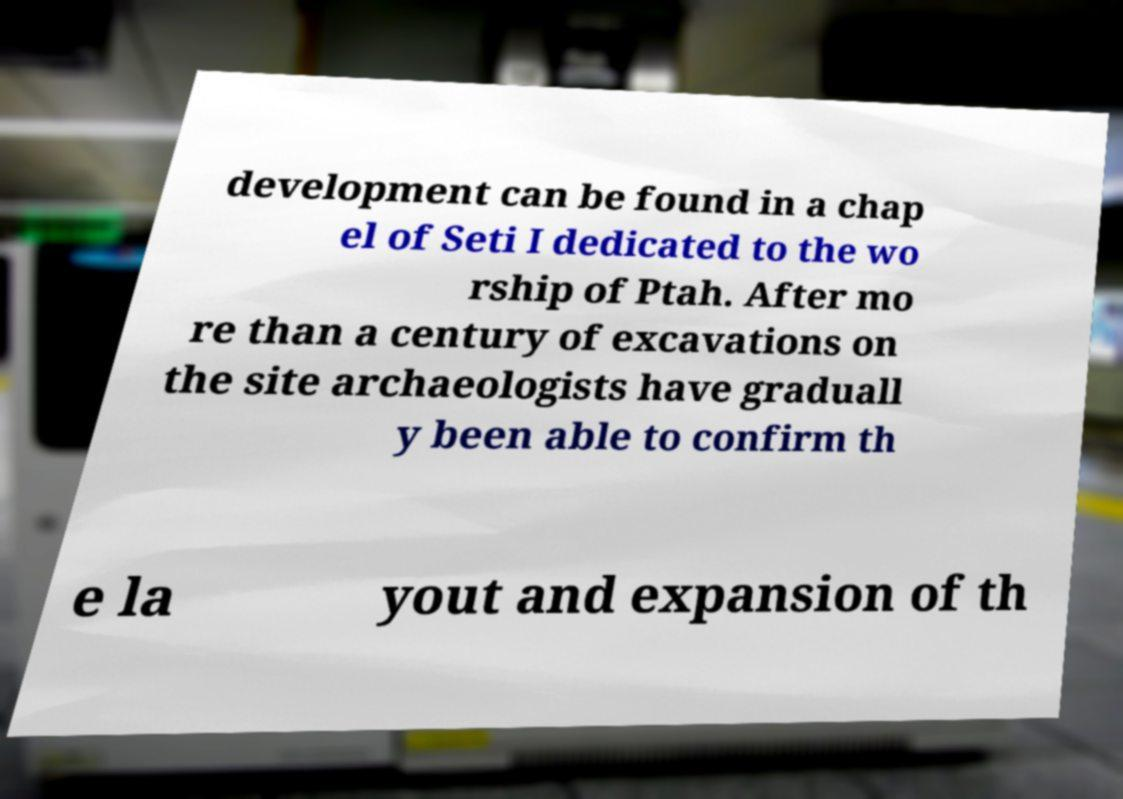For documentation purposes, I need the text within this image transcribed. Could you provide that? development can be found in a chap el of Seti I dedicated to the wo rship of Ptah. After mo re than a century of excavations on the site archaeologists have graduall y been able to confirm th e la yout and expansion of th 